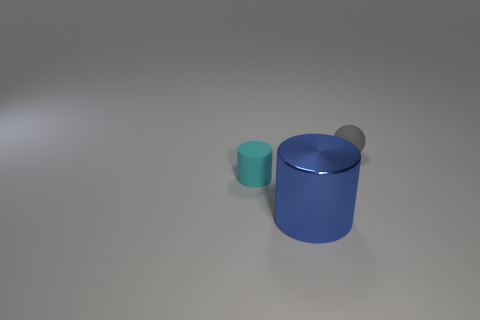Add 2 small gray matte things. How many objects exist? 5 Subtract all cylinders. How many objects are left? 1 Add 1 rubber balls. How many rubber balls exist? 2 Subtract 1 cyan cylinders. How many objects are left? 2 Subtract all tiny red rubber cylinders. Subtract all metal cylinders. How many objects are left? 2 Add 1 small matte things. How many small matte things are left? 3 